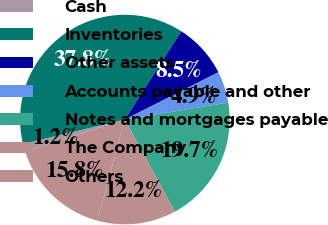Convert chart to OTSL. <chart><loc_0><loc_0><loc_500><loc_500><pie_chart><fcel>Cash<fcel>Inventories<fcel>Other assets<fcel>Accounts payable and other<fcel>Notes and mortgages payable<fcel>The Company<fcel>Others<nl><fcel>1.19%<fcel>37.78%<fcel>8.5%<fcel>4.85%<fcel>19.7%<fcel>12.16%<fcel>15.82%<nl></chart> 